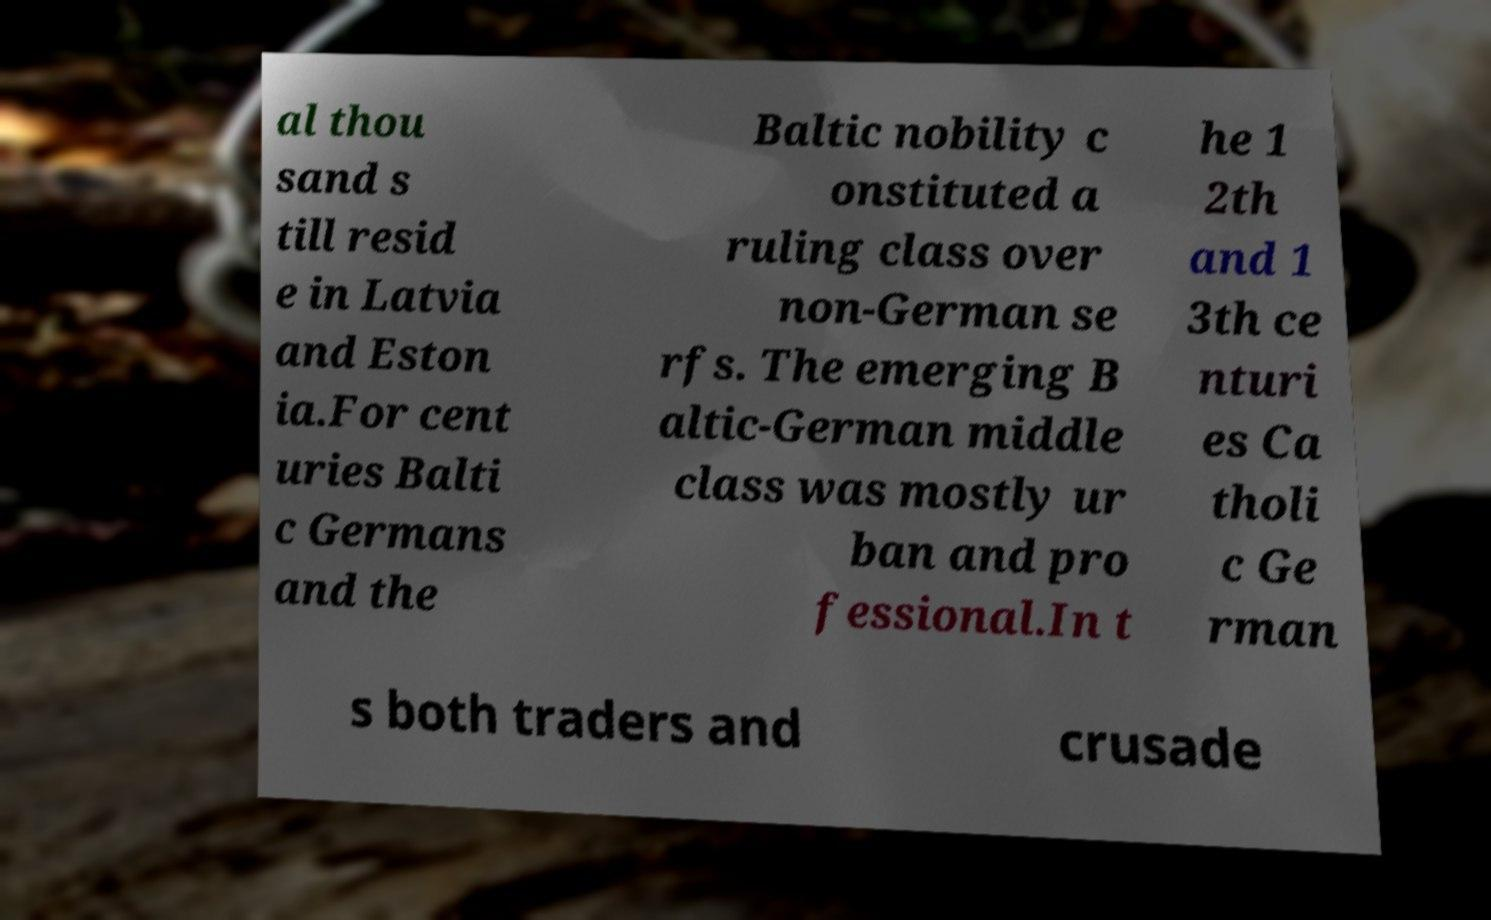For documentation purposes, I need the text within this image transcribed. Could you provide that? al thou sand s till resid e in Latvia and Eston ia.For cent uries Balti c Germans and the Baltic nobility c onstituted a ruling class over non-German se rfs. The emerging B altic-German middle class was mostly ur ban and pro fessional.In t he 1 2th and 1 3th ce nturi es Ca tholi c Ge rman s both traders and crusade 